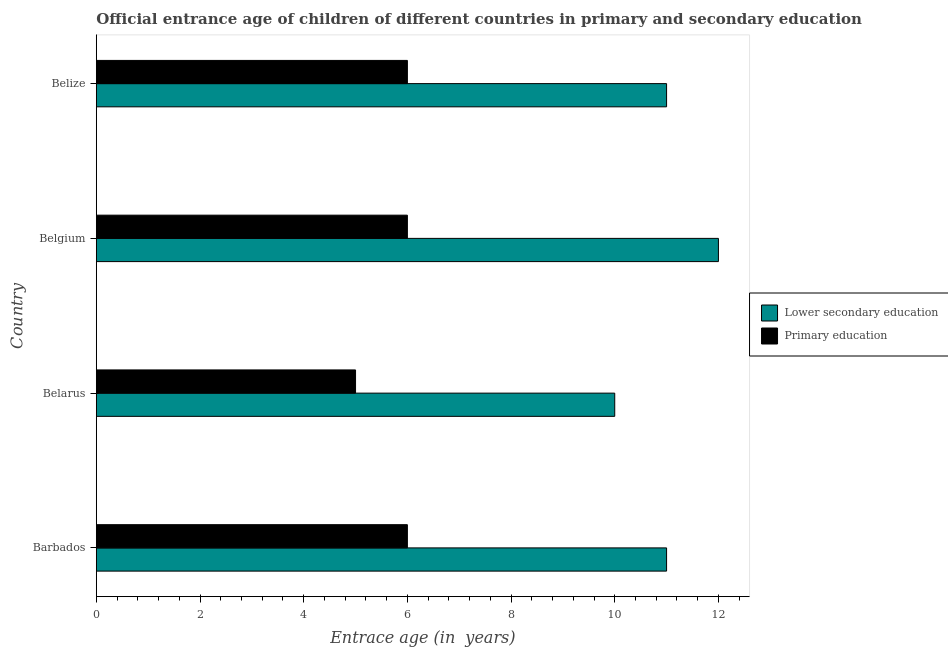Are the number of bars per tick equal to the number of legend labels?
Offer a very short reply. Yes. Are the number of bars on each tick of the Y-axis equal?
Provide a succinct answer. Yes. How many bars are there on the 3rd tick from the bottom?
Provide a short and direct response. 2. What is the label of the 3rd group of bars from the top?
Give a very brief answer. Belarus. What is the entrance age of children in lower secondary education in Belarus?
Your response must be concise. 10. Across all countries, what is the maximum entrance age of chiildren in primary education?
Your response must be concise. 6. Across all countries, what is the minimum entrance age of chiildren in primary education?
Your answer should be compact. 5. In which country was the entrance age of chiildren in primary education maximum?
Give a very brief answer. Barbados. In which country was the entrance age of children in lower secondary education minimum?
Your response must be concise. Belarus. What is the total entrance age of children in lower secondary education in the graph?
Provide a succinct answer. 44. What is the difference between the entrance age of children in lower secondary education in Belarus and that in Belize?
Keep it short and to the point. -1. What is the difference between the entrance age of chiildren in primary education in Belgium and the entrance age of children in lower secondary education in Belarus?
Make the answer very short. -4. What is the average entrance age of chiildren in primary education per country?
Give a very brief answer. 5.75. What is the difference between the entrance age of chiildren in primary education and entrance age of children in lower secondary education in Belarus?
Give a very brief answer. -5. What is the ratio of the entrance age of children in lower secondary education in Belarus to that in Belize?
Give a very brief answer. 0.91. Is the difference between the entrance age of children in lower secondary education in Barbados and Belgium greater than the difference between the entrance age of chiildren in primary education in Barbados and Belgium?
Your response must be concise. No. What is the difference between the highest and the second highest entrance age of chiildren in primary education?
Your answer should be very brief. 0. What is the difference between the highest and the lowest entrance age of chiildren in primary education?
Offer a very short reply. 1. What does the 2nd bar from the top in Belize represents?
Provide a short and direct response. Lower secondary education. What does the 2nd bar from the bottom in Belize represents?
Make the answer very short. Primary education. Are all the bars in the graph horizontal?
Give a very brief answer. Yes. What is the difference between two consecutive major ticks on the X-axis?
Offer a terse response. 2. Are the values on the major ticks of X-axis written in scientific E-notation?
Offer a very short reply. No. Does the graph contain any zero values?
Your response must be concise. No. Where does the legend appear in the graph?
Your response must be concise. Center right. How are the legend labels stacked?
Give a very brief answer. Vertical. What is the title of the graph?
Ensure brevity in your answer.  Official entrance age of children of different countries in primary and secondary education. What is the label or title of the X-axis?
Give a very brief answer. Entrace age (in  years). What is the label or title of the Y-axis?
Your response must be concise. Country. What is the Entrace age (in  years) of Lower secondary education in Barbados?
Provide a succinct answer. 11. What is the Entrace age (in  years) of Primary education in Barbados?
Keep it short and to the point. 6. What is the Entrace age (in  years) in Lower secondary education in Belarus?
Offer a very short reply. 10. What is the Entrace age (in  years) of Lower secondary education in Belgium?
Your answer should be very brief. 12. What is the Entrace age (in  years) in Lower secondary education in Belize?
Your answer should be compact. 11. Across all countries, what is the maximum Entrace age (in  years) of Lower secondary education?
Make the answer very short. 12. Across all countries, what is the minimum Entrace age (in  years) of Lower secondary education?
Offer a terse response. 10. What is the total Entrace age (in  years) in Primary education in the graph?
Give a very brief answer. 23. What is the difference between the Entrace age (in  years) in Lower secondary education in Barbados and that in Belarus?
Give a very brief answer. 1. What is the difference between the Entrace age (in  years) of Primary education in Barbados and that in Belize?
Keep it short and to the point. 0. What is the difference between the Entrace age (in  years) in Lower secondary education in Belarus and that in Belgium?
Offer a very short reply. -2. What is the difference between the Entrace age (in  years) of Lower secondary education in Belarus and that in Belize?
Your response must be concise. -1. What is the difference between the Entrace age (in  years) of Primary education in Belarus and that in Belize?
Your answer should be compact. -1. What is the difference between the Entrace age (in  years) in Primary education in Belgium and that in Belize?
Your response must be concise. 0. What is the difference between the Entrace age (in  years) in Lower secondary education in Belarus and the Entrace age (in  years) in Primary education in Belgium?
Provide a short and direct response. 4. What is the difference between the Entrace age (in  years) of Lower secondary education in Belgium and the Entrace age (in  years) of Primary education in Belize?
Provide a succinct answer. 6. What is the average Entrace age (in  years) in Primary education per country?
Provide a succinct answer. 5.75. What is the difference between the Entrace age (in  years) of Lower secondary education and Entrace age (in  years) of Primary education in Barbados?
Ensure brevity in your answer.  5. What is the difference between the Entrace age (in  years) in Lower secondary education and Entrace age (in  years) in Primary education in Belarus?
Your response must be concise. 5. What is the difference between the Entrace age (in  years) of Lower secondary education and Entrace age (in  years) of Primary education in Belgium?
Ensure brevity in your answer.  6. What is the difference between the Entrace age (in  years) in Lower secondary education and Entrace age (in  years) in Primary education in Belize?
Give a very brief answer. 5. What is the ratio of the Entrace age (in  years) of Lower secondary education in Barbados to that in Belize?
Your answer should be compact. 1. What is the ratio of the Entrace age (in  years) in Primary education in Belarus to that in Belgium?
Offer a terse response. 0.83. What is the ratio of the Entrace age (in  years) in Lower secondary education in Belarus to that in Belize?
Keep it short and to the point. 0.91. What is the ratio of the Entrace age (in  years) of Primary education in Belarus to that in Belize?
Your answer should be compact. 0.83. What is the ratio of the Entrace age (in  years) of Lower secondary education in Belgium to that in Belize?
Ensure brevity in your answer.  1.09. What is the ratio of the Entrace age (in  years) of Primary education in Belgium to that in Belize?
Provide a short and direct response. 1. 